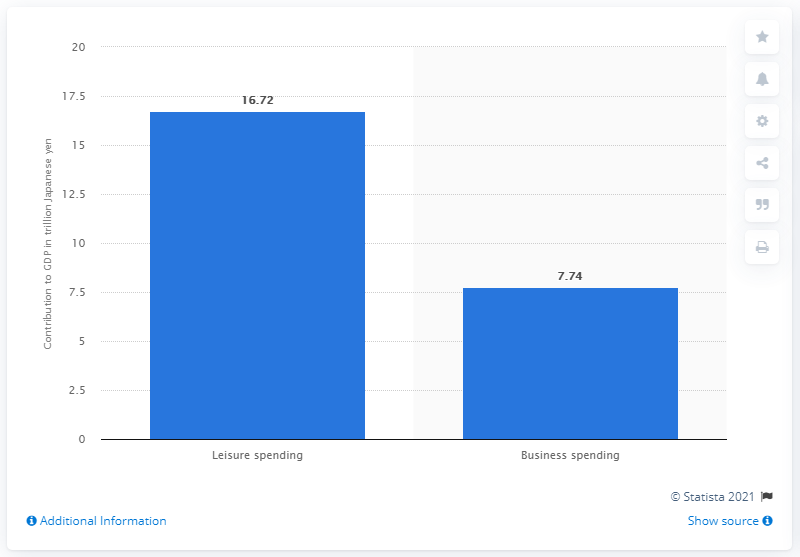Draw attention to some important aspects in this diagram. In 2017, leisure travel generated 16.72 billion US dollars of direct travel and tourism GDP in Japan. 